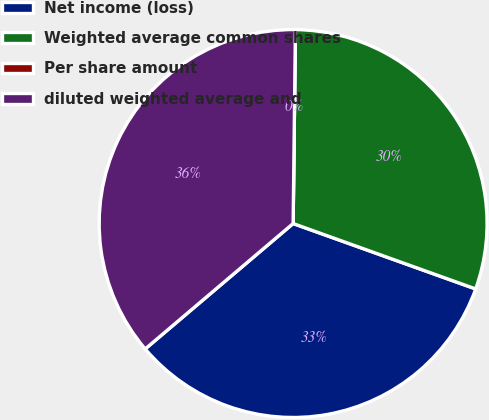Convert chart to OTSL. <chart><loc_0><loc_0><loc_500><loc_500><pie_chart><fcel>Net income (loss)<fcel>Weighted average common shares<fcel>Per share amount<fcel>diluted weighted average and<nl><fcel>33.33%<fcel>30.29%<fcel>0.0%<fcel>36.38%<nl></chart> 